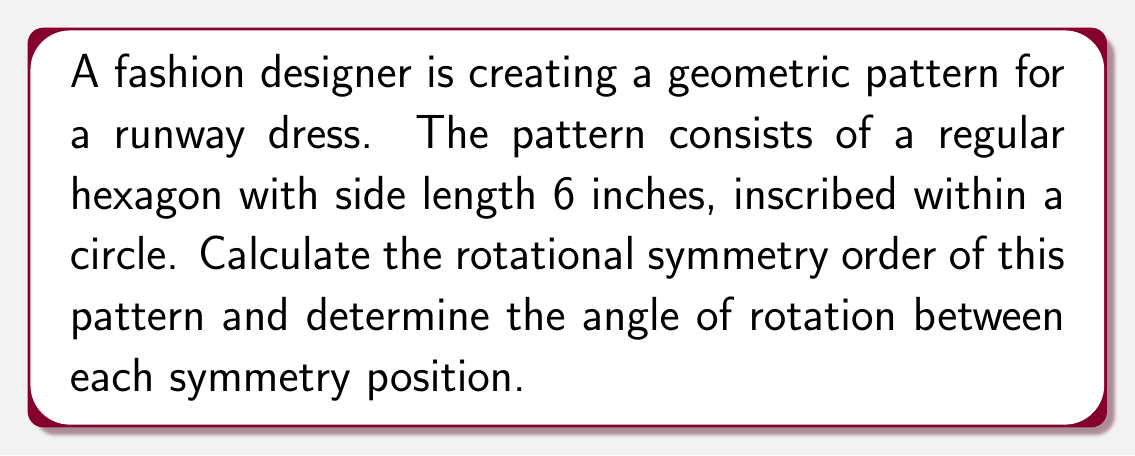Provide a solution to this math problem. To solve this problem, we'll follow these steps:

1) First, let's recall that the rotational symmetry order of a regular polygon is equal to the number of sides it has. In this case, we have a regular hexagon.

   Rotational symmetry order = 6

2) To find the angle of rotation between each symmetry position, we need to divide the full rotation (360°) by the rotational symmetry order:

   $$\text{Angle of rotation} = \frac{360°}{\text{Rotational symmetry order}} = \frac{360°}{6} = 60°$$

3) We can verify this visually:

[asy]
unitsize(10mm);
path hexagon = (1,0)--(0.5,0.866)--(-0.5,0.866)--(-1,0)--(-0.5,-0.866)--(0.5,-0.866)--cycle;
draw(circle((0,0),1), rgb(0.7,0.7,0.7));
draw(hexagon, rgb(0,0,0)+linewidth(0.8));
draw((0,0)--(1,0), rgb(0.5,0.5,0.5), Arrow);
draw((0,0)--(0.5,0.866), rgb(0.5,0.5,0.5), Arrow);
label("60°", (0.4,0.2), rgb(0.5,0.5,0.5));
[/asy]

This diagram shows the hexagon inscribed in a circle, with two arrows indicating the 60° rotation between symmetry positions.

4) In terms of fashion design, this means that the pattern will look identical when rotated by 60°, 120°, 180°, 240°, 300°, and 360° (back to the starting position).
Answer: Rotational symmetry order: 6, Angle of rotation: 60° 